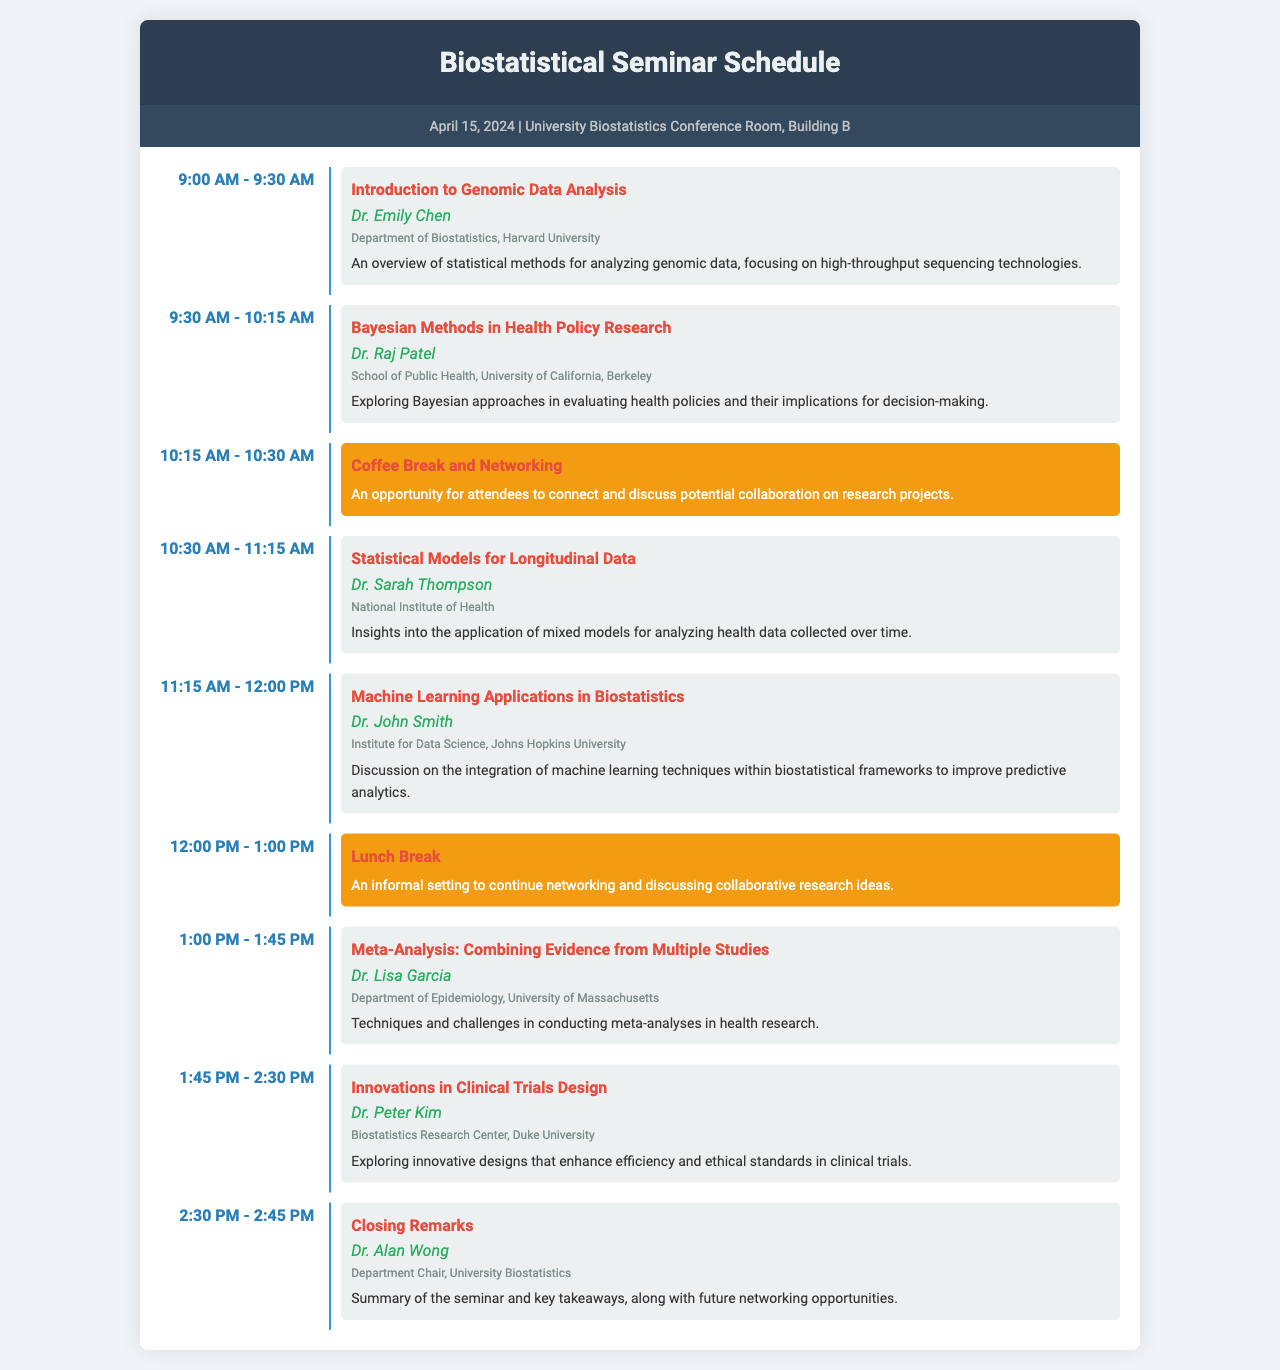What is the date of the seminar? The date of the seminar is explicitly mentioned in the document.
Answer: April 15, 2024 Who is the speaker for the introduction to genomic data analysis? The document provides the name of the speaker associated with this topic.
Answer: Dr. Emily Chen What is the duration of the coffee break? The document indicates the schedule time for the coffee break, which helps to determine its duration.
Answer: 15 minutes Which topic is presented by Dr. Lisa Garcia? The document lists the topic associated with Dr. Lisa Garcia in the schedule.
Answer: Meta-Analysis: Combining Evidence from Multiple Studies How many presentations are scheduled before lunch? The document shows the schedule of presentations before the lunch break.
Answer: Four presentations What is the affiliation of the speaker Dr. Raj Patel? The document specifies the affiliation of Dr. Raj Patel.
Answer: School of Public Health, University of California, Berkeley What is the main focus of Dr. John's presentation? The document includes a brief description of Dr. John's topic, which reveals its main focus.
Answer: Machine Learning Applications in Biostatistics Is there a networking opportunity during the seminar? The document outlines specific times for networking as part of the seminar agenda.
Answer: Yes What time does the seminar start? The schedule shows the starting time of the first event in the seminar.
Answer: 9:00 AM 